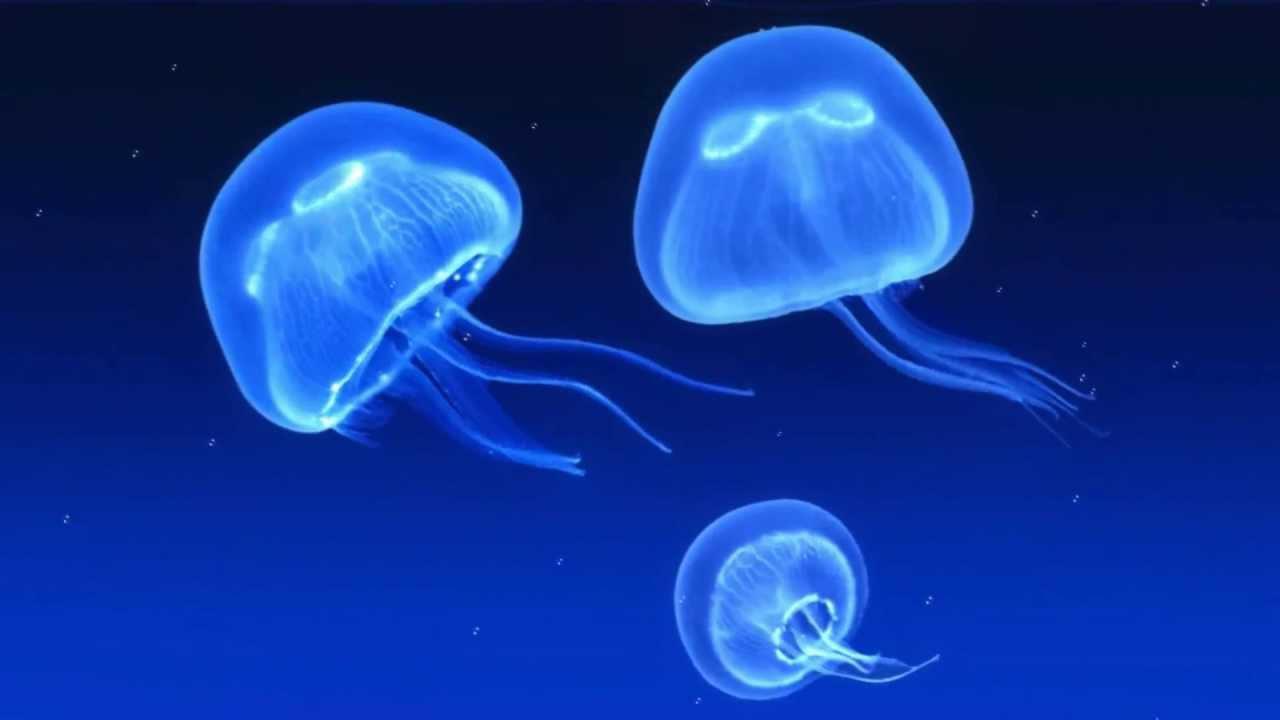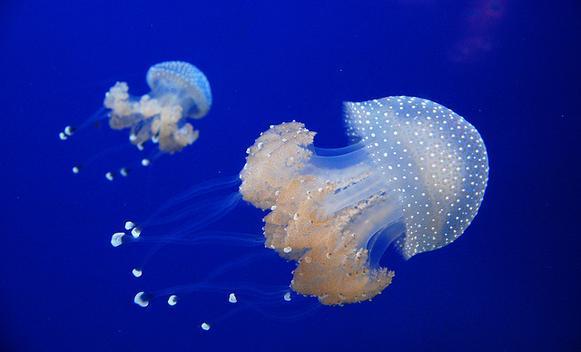The first image is the image on the left, the second image is the image on the right. Examine the images to the left and right. Is the description "there is only one jellyfish on one of the images" accurate? Answer yes or no. No. 